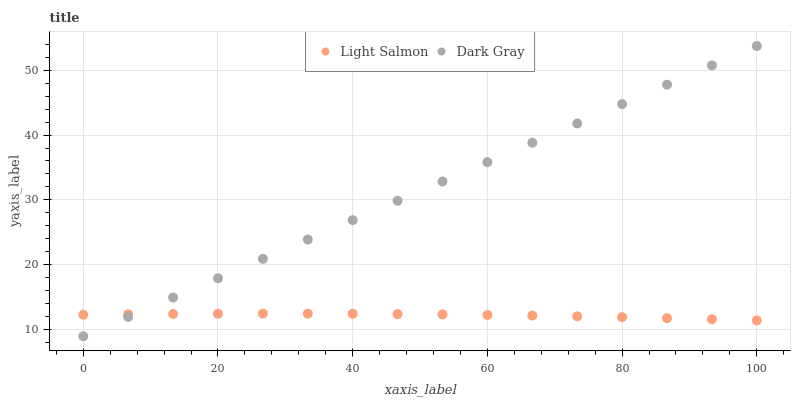Does Light Salmon have the minimum area under the curve?
Answer yes or no. Yes. Does Dark Gray have the maximum area under the curve?
Answer yes or no. Yes. Does Light Salmon have the maximum area under the curve?
Answer yes or no. No. Is Dark Gray the smoothest?
Answer yes or no. Yes. Is Light Salmon the roughest?
Answer yes or no. Yes. Is Light Salmon the smoothest?
Answer yes or no. No. Does Dark Gray have the lowest value?
Answer yes or no. Yes. Does Light Salmon have the lowest value?
Answer yes or no. No. Does Dark Gray have the highest value?
Answer yes or no. Yes. Does Light Salmon have the highest value?
Answer yes or no. No. Does Light Salmon intersect Dark Gray?
Answer yes or no. Yes. Is Light Salmon less than Dark Gray?
Answer yes or no. No. Is Light Salmon greater than Dark Gray?
Answer yes or no. No. 